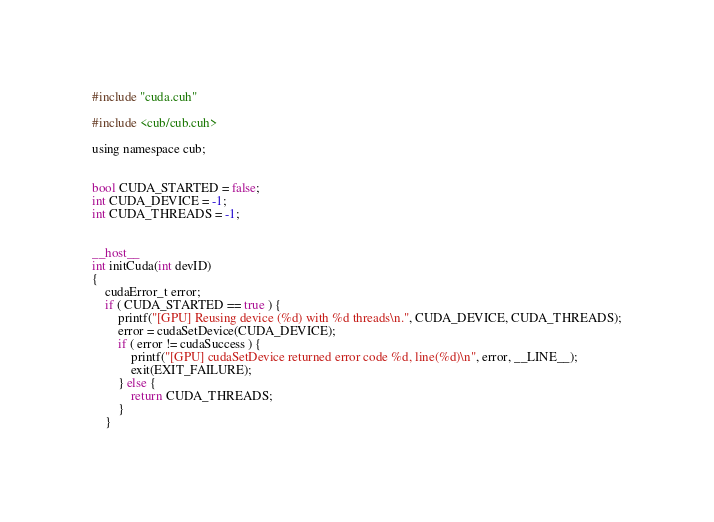Convert code to text. <code><loc_0><loc_0><loc_500><loc_500><_Cuda_>
#include "cuda.cuh"

#include <cub/cub.cuh>

using namespace cub;


bool CUDA_STARTED = false;
int CUDA_DEVICE = -1;
int CUDA_THREADS = -1;


__host__
int initCuda(int devID)
{
    cudaError_t error;
    if ( CUDA_STARTED == true ) {
        printf("[GPU] Reusing device (%d) with %d threads\n.", CUDA_DEVICE, CUDA_THREADS);
        error = cudaSetDevice(CUDA_DEVICE);
        if ( error != cudaSuccess ) {
            printf("[GPU] cudaSetDevice returned error code %d, line(%d)\n", error, __LINE__);
            exit(EXIT_FAILURE);
        } else {
            return CUDA_THREADS;
        }
    }
</code> 